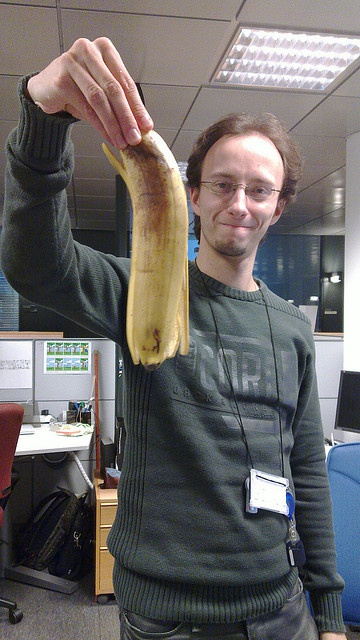Describe the objects in this image and their specific colors. I can see people in gray and black tones, banana in gray, tan, and maroon tones, chair in gray, blue, and navy tones, backpack in gray, black, and darkgreen tones, and backpack in gray, black, and navy tones in this image. 